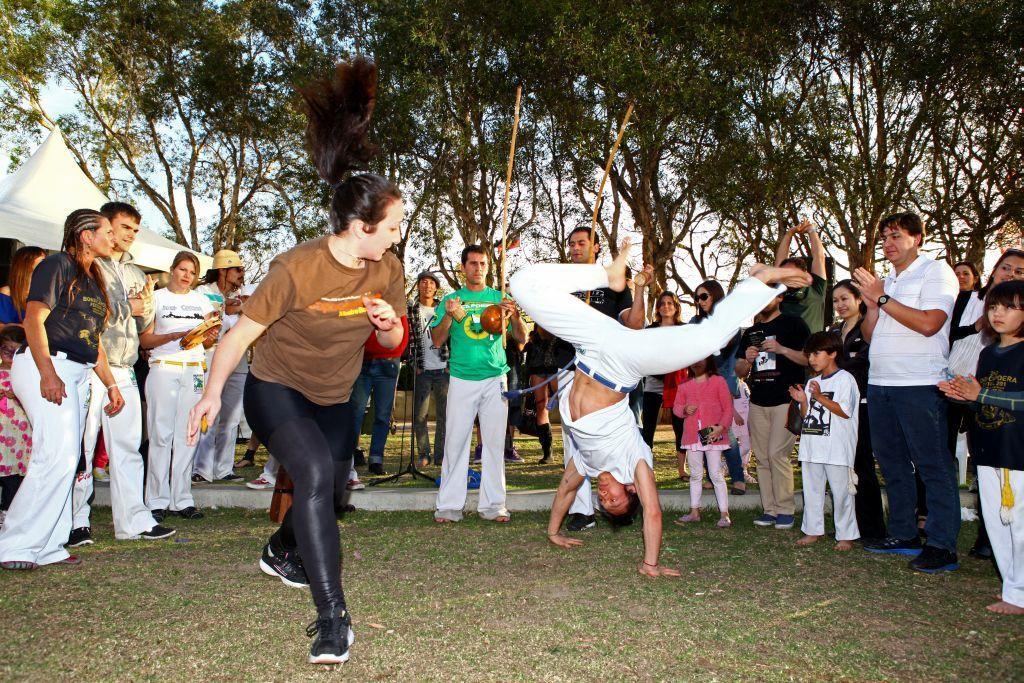Could you give a brief overview of what you see in this image? There are group of people standing and watching. Here is a person standing upside down. This is the woman dancing. This looks like a canopy tent, which is white in color. These are the trees. This is the grass. 